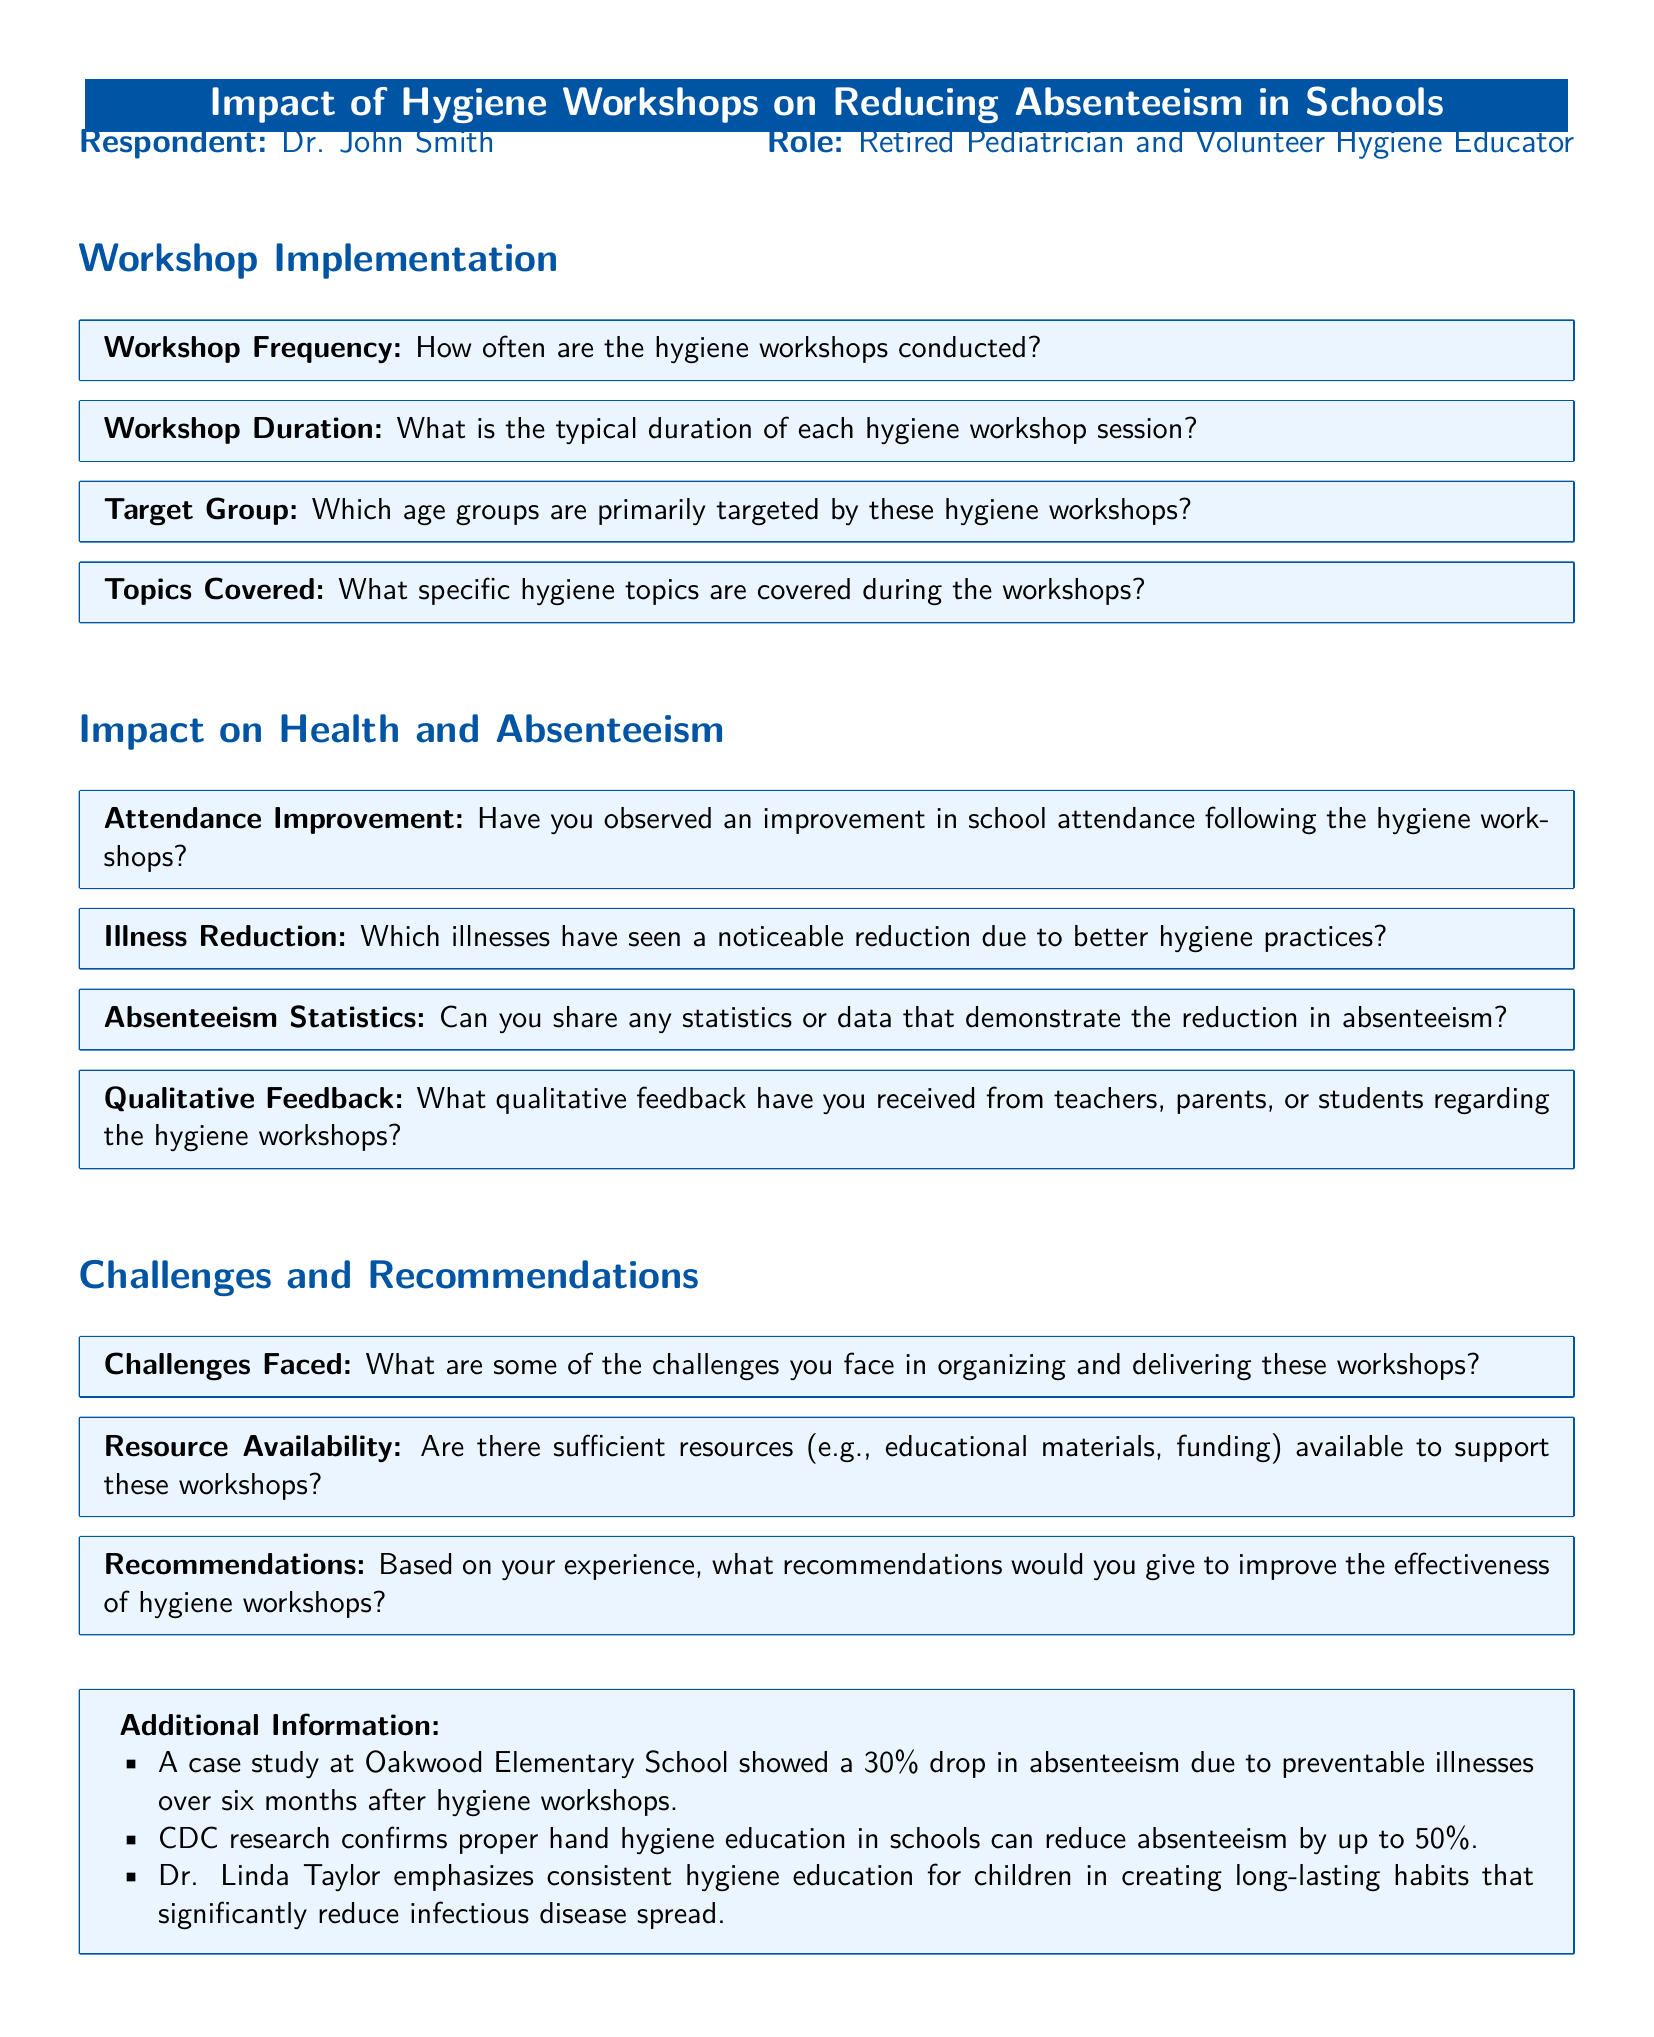What is the typical duration of each hygiene workshop session? The document specifies the typical duration of the hygiene workshop sessions, although it may not mention an exact time.
Answer: Not specified Which age groups are primarily targeted by these hygiene workshops? The document asks about the target age groups, identifying specific demographics addressed by the workshops.
Answer: Not specified What is the percentage drop in absenteeism observed at Oakwood Elementary School? The document notes a case study indicating a 30% drop in absenteeism following the workshops.
Answer: 30% What does CDC research confirm about hand hygiene education in schools? The document states that CDC research confirms proper hand hygiene education can reduce absenteeism by up to 50%.
Answer: 50% What qualitative feedback have you received regarding the hygiene workshops? The document seeks qualitative feedback, highlighting the subjective responses from teachers, parents, or students related to the workshops.
Answer: Not specified What challenges do you face in organizing these workshops? The document prompts a response regarding challenges faced while organizing and delivering the workshops.
Answer: Not specified Are there sufficient resources available to support these workshops? The document inquires about the availability of resources, including educational materials and funding, to support the workshops.
Answer: Not specified What specific hygiene topics are covered during the workshops? The document asks for details about the hygiene topics discussed in the workshops to provide insights into the program's focus.
Answer: Not specified 